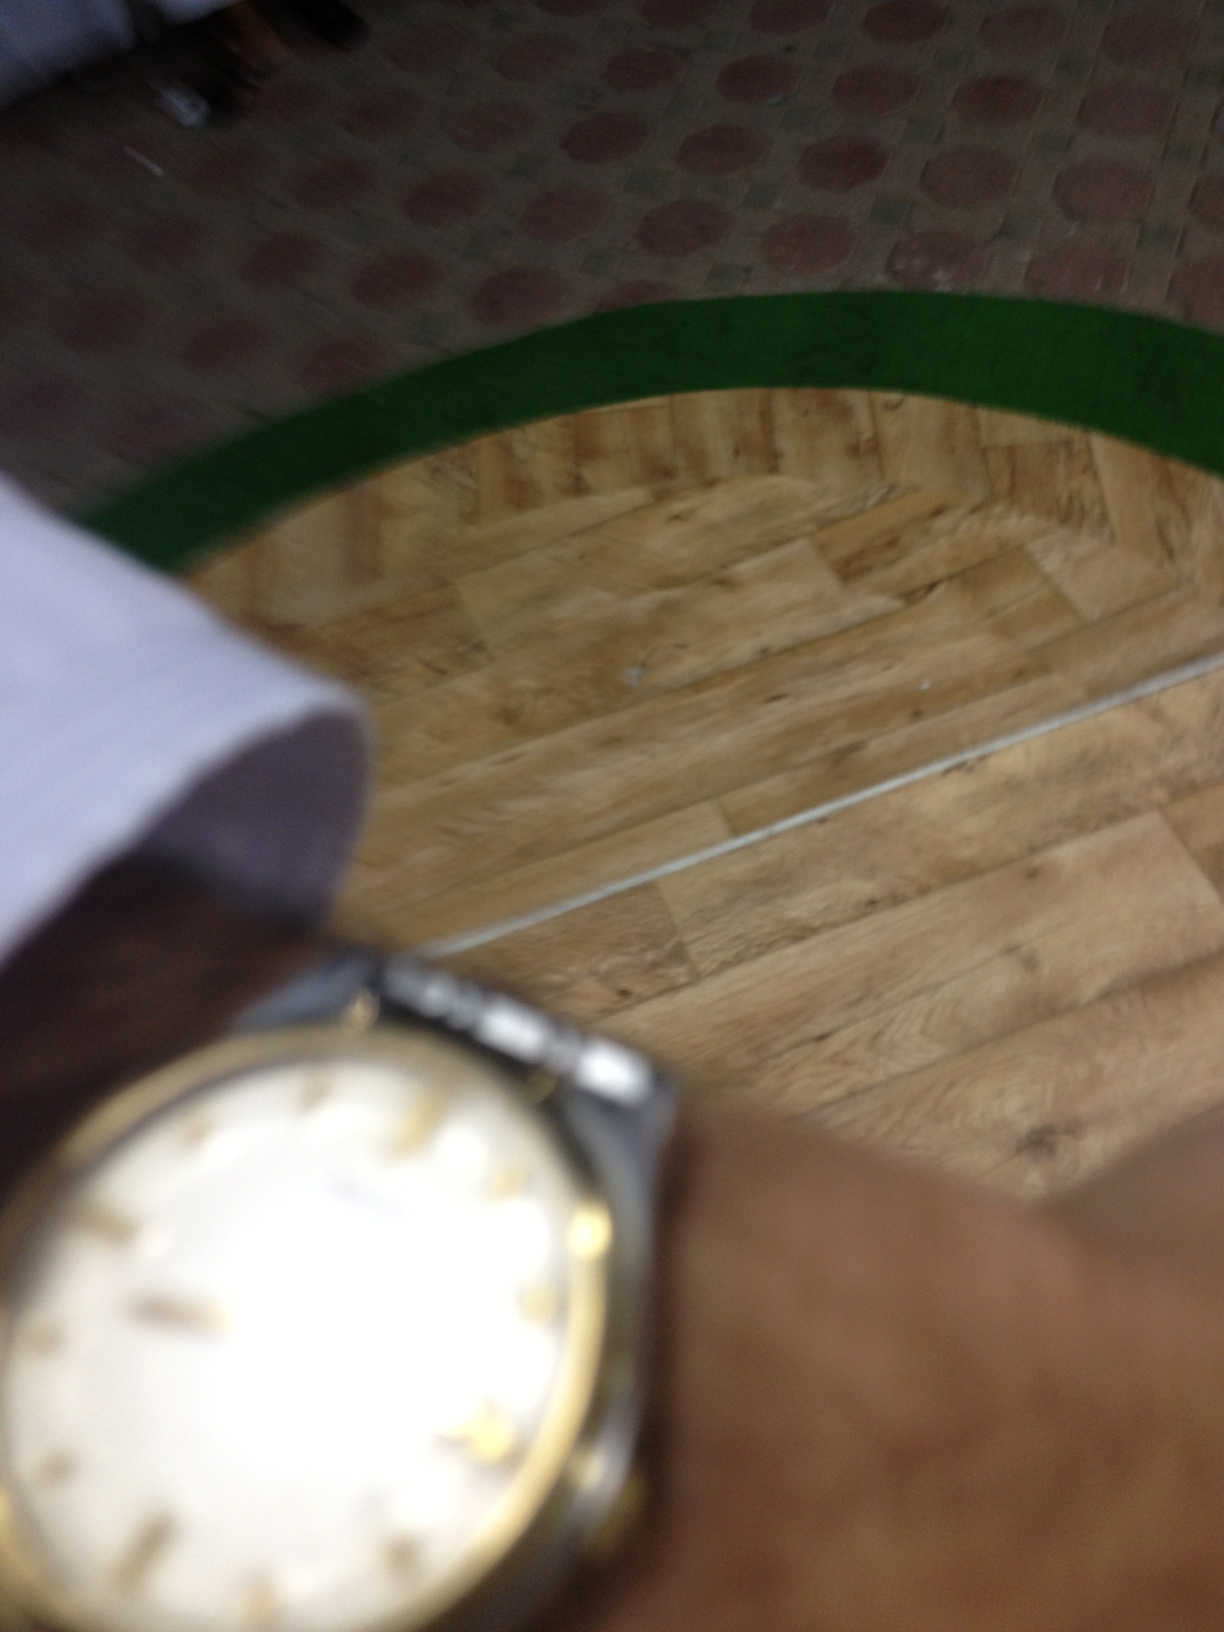What can you infer about the setting or context in which this photo was taken? The background, although blurred, shows a wooden floor and part of a green textured strip, possibly a runner mat. This suggests the photo might have been taken indoors, perhaps in a home or small interior space like a shop or office. 